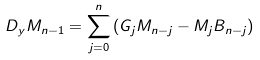Convert formula to latex. <formula><loc_0><loc_0><loc_500><loc_500>D _ { y } M _ { n - 1 } = \sum _ { j = 0 } ^ { n } \left ( G _ { j } M _ { n - j } - M _ { j } B _ { n - j } \right )</formula> 